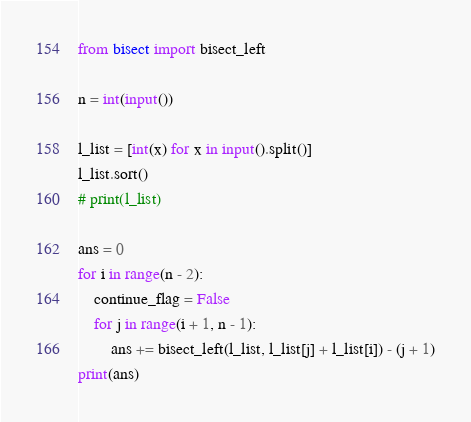Convert code to text. <code><loc_0><loc_0><loc_500><loc_500><_Python_>from bisect import bisect_left

n = int(input())

l_list = [int(x) for x in input().split()]
l_list.sort()
# print(l_list)

ans = 0
for i in range(n - 2):
    continue_flag = False
    for j in range(i + 1, n - 1):
        ans += bisect_left(l_list, l_list[j] + l_list[i]) - (j + 1)
print(ans)</code> 